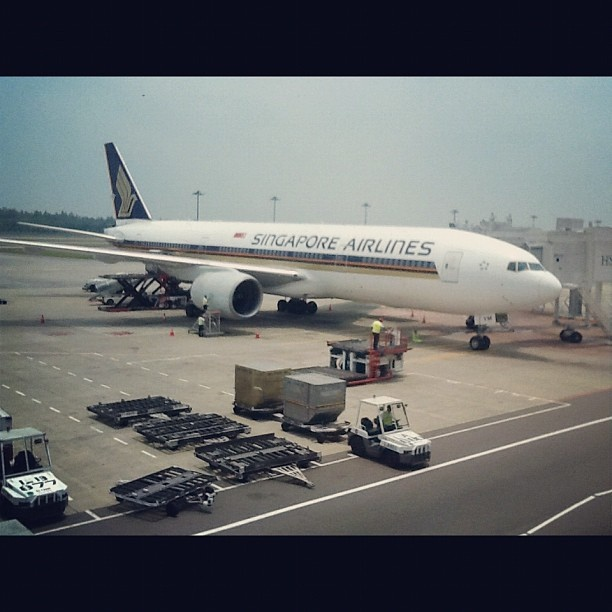Describe the objects in this image and their specific colors. I can see airplane in black, darkgray, lightgray, and gray tones, truck in black, gray, darkgray, and lightgray tones, truck in black, gray, ivory, and darkgray tones, people in black, gray, tan, and khaki tones, and people in black, gray, darkgreen, and darkgray tones in this image. 